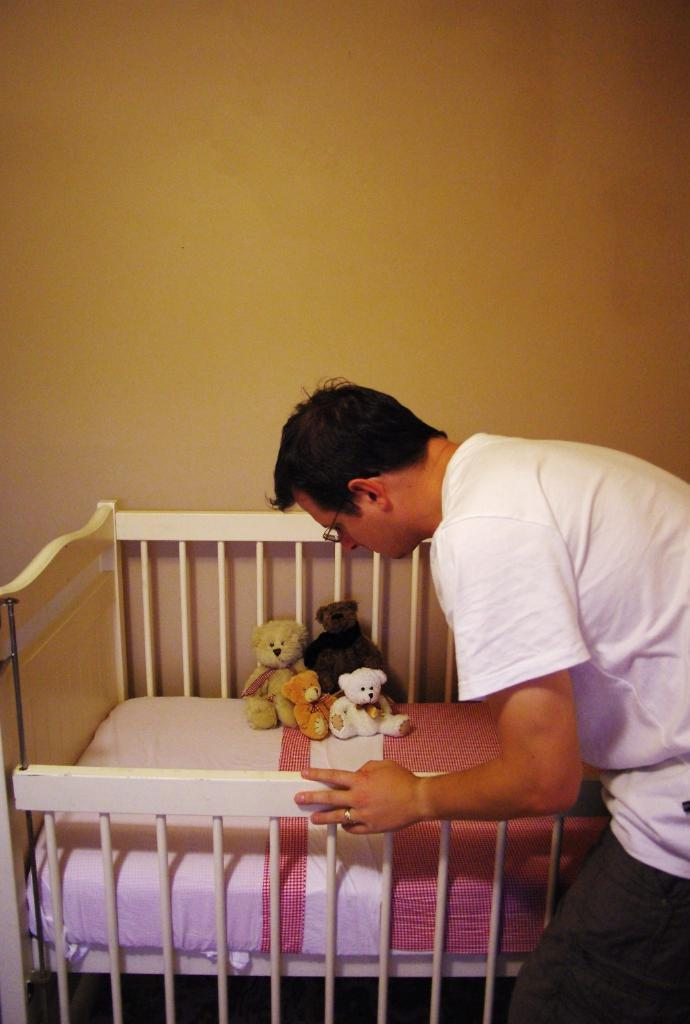What is the person standing beside in the image? There is a person standing beside a bed in the image. What is on the bed in the image? There are dolls on the bed in the image. What is the cause of the volcanic eruption in the image? There is no volcanic eruption present in the image; it only features a person standing beside a bed with dolls on it. 